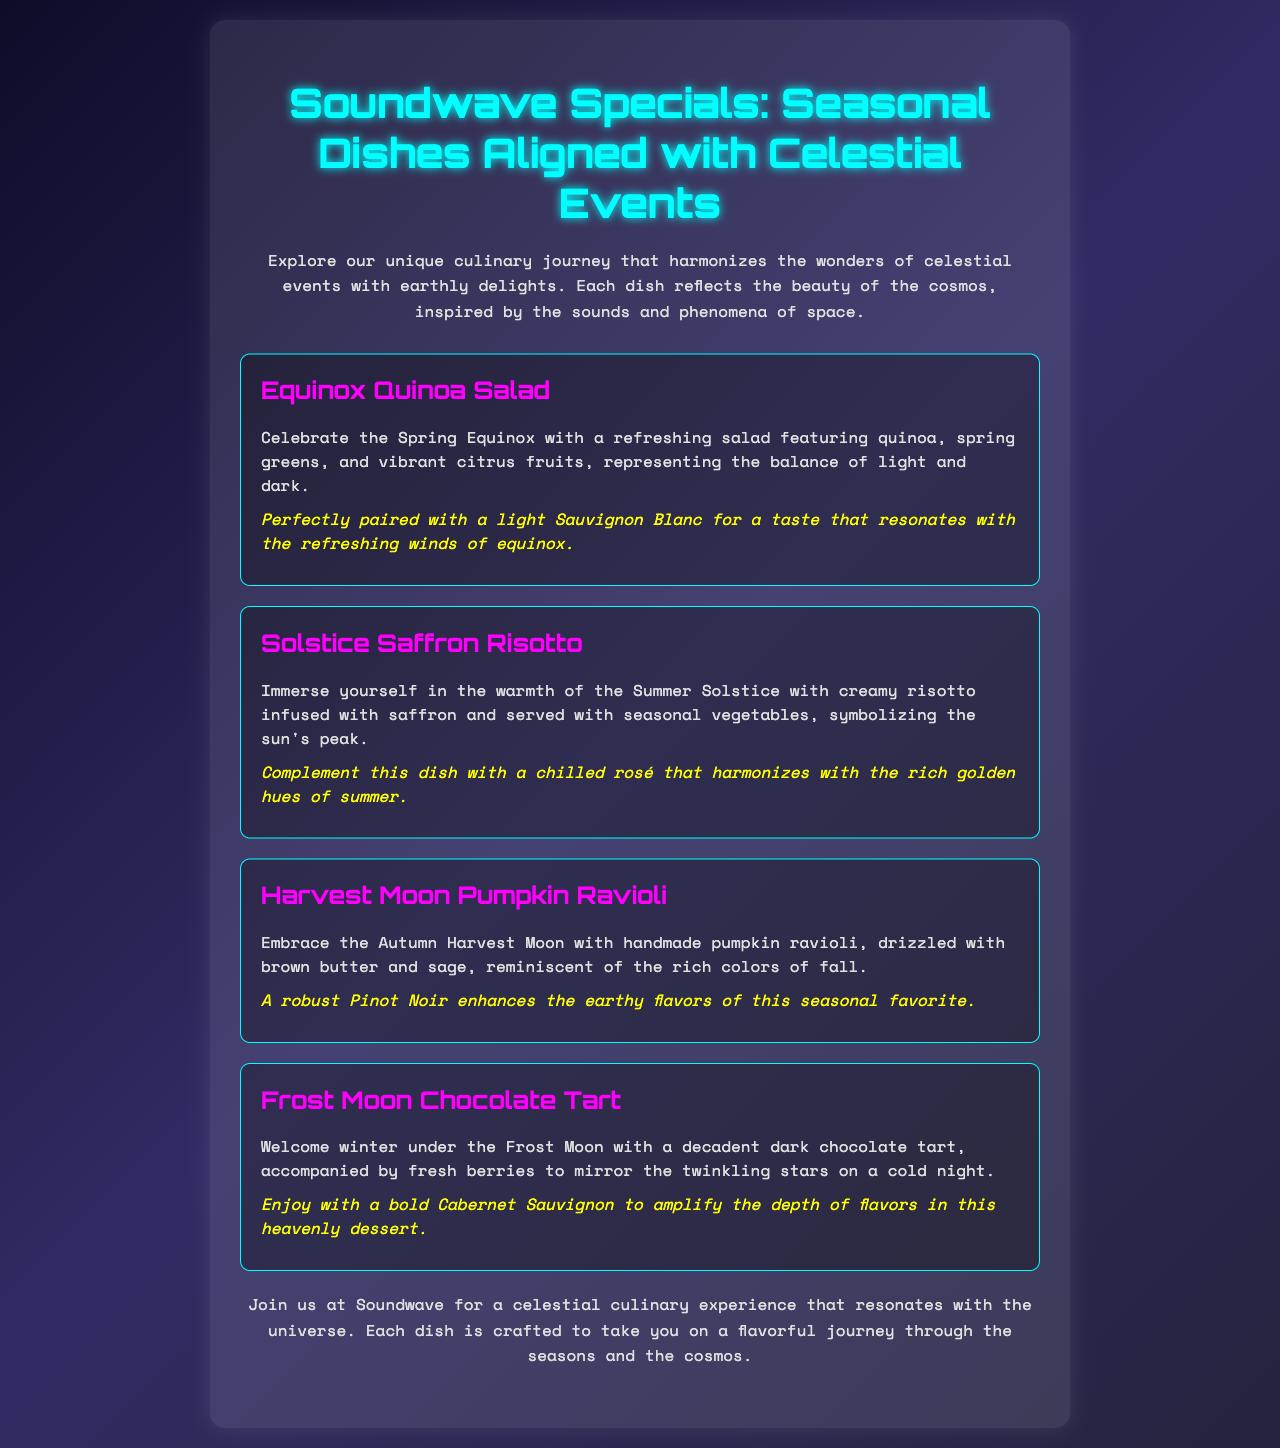what is the title of the menu? The title of the menu is prominently displayed at the top of the document, showcasing the theme of the dishes.
Answer: Soundwave Specials: Seasonal Dishes Aligned with Celestial Events how many seasonal dishes are listed in the menu? The menu includes a total of four distinct dishes that are seasonal and aligned with celestial events.
Answer: 4 what dish is served with a light Sauvignon Blanc? The pairing for this dish is specified to enhance the flavors and is mentioned alongside the dish's description.
Answer: Equinox Quinoa Salad which season does the Frost Moon chocolate tart represent? The dish's description indicates it embodies the characteristics of the specific seasonal event it is associated with.
Answer: Winter what is the main ingredient in the Harvest Moon pumpkin ravioli? The dish's description highlights the essential ingredient that defines its culinary character and flavor.
Answer: Pumpkin 